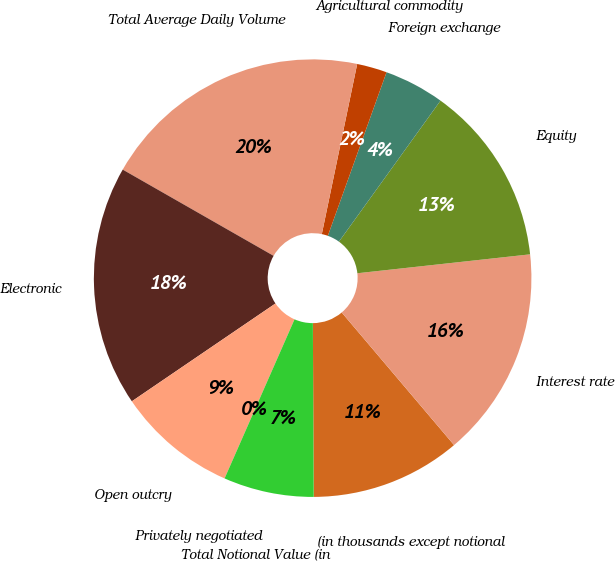Convert chart. <chart><loc_0><loc_0><loc_500><loc_500><pie_chart><fcel>(in thousands except notional<fcel>Interest rate<fcel>Equity<fcel>Foreign exchange<fcel>Agricultural commodity<fcel>Total Average Daily Volume<fcel>Electronic<fcel>Open outcry<fcel>Privately negotiated<fcel>Total Notional Value (in<nl><fcel>11.11%<fcel>15.55%<fcel>13.33%<fcel>4.45%<fcel>2.22%<fcel>20.0%<fcel>17.78%<fcel>8.89%<fcel>0.0%<fcel>6.67%<nl></chart> 